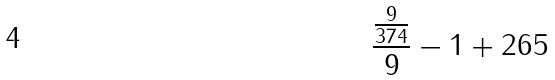Convert formula to latex. <formula><loc_0><loc_0><loc_500><loc_500>\frac { \frac { 9 } { 3 7 4 } } { 9 } - 1 + 2 6 5</formula> 